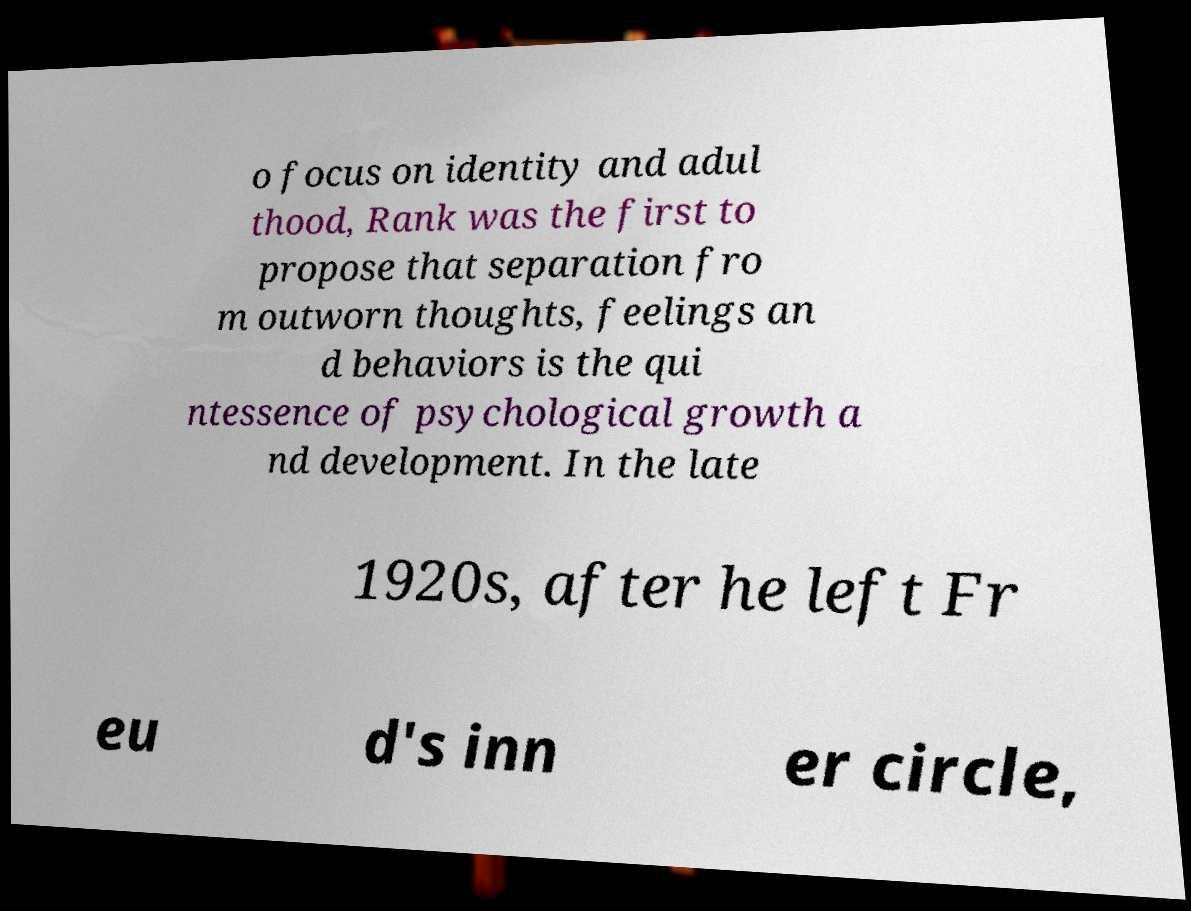Please read and relay the text visible in this image. What does it say? o focus on identity and adul thood, Rank was the first to propose that separation fro m outworn thoughts, feelings an d behaviors is the qui ntessence of psychological growth a nd development. In the late 1920s, after he left Fr eu d's inn er circle, 